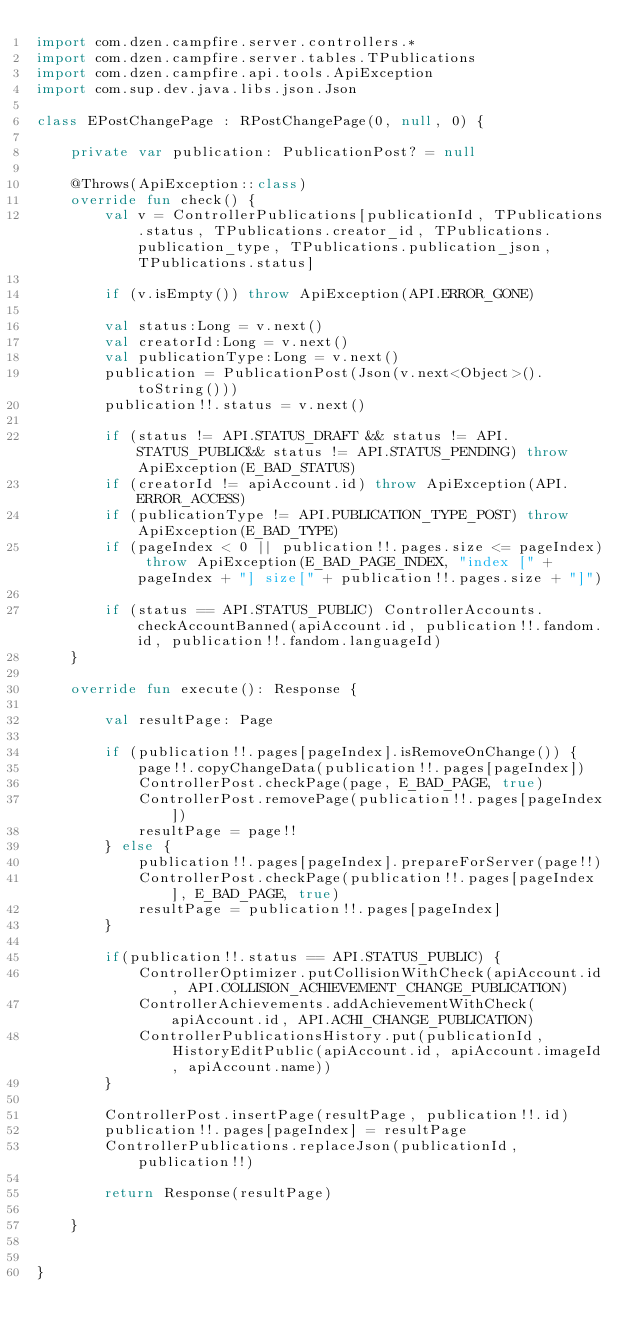<code> <loc_0><loc_0><loc_500><loc_500><_Kotlin_>import com.dzen.campfire.server.controllers.*
import com.dzen.campfire.server.tables.TPublications
import com.dzen.campfire.api.tools.ApiException
import com.sup.dev.java.libs.json.Json

class EPostChangePage : RPostChangePage(0, null, 0) {

    private var publication: PublicationPost? = null

    @Throws(ApiException::class)
    override fun check() {
        val v = ControllerPublications[publicationId, TPublications.status, TPublications.creator_id, TPublications.publication_type, TPublications.publication_json, TPublications.status]

        if (v.isEmpty()) throw ApiException(API.ERROR_GONE)

        val status:Long = v.next()
        val creatorId:Long = v.next()
        val publicationType:Long = v.next()
        publication = PublicationPost(Json(v.next<Object>().toString()))
        publication!!.status = v.next()

        if (status != API.STATUS_DRAFT && status != API.STATUS_PUBLIC&& status != API.STATUS_PENDING) throw ApiException(E_BAD_STATUS)
        if (creatorId != apiAccount.id) throw ApiException(API.ERROR_ACCESS)
        if (publicationType != API.PUBLICATION_TYPE_POST) throw ApiException(E_BAD_TYPE)
        if (pageIndex < 0 || publication!!.pages.size <= pageIndex) throw ApiException(E_BAD_PAGE_INDEX, "index [" + pageIndex + "] size[" + publication!!.pages.size + "]")

        if (status == API.STATUS_PUBLIC) ControllerAccounts.checkAccountBanned(apiAccount.id, publication!!.fandom.id, publication!!.fandom.languageId)
    }

    override fun execute(): Response {

        val resultPage: Page

        if (publication!!.pages[pageIndex].isRemoveOnChange()) {
            page!!.copyChangeData(publication!!.pages[pageIndex])
            ControllerPost.checkPage(page, E_BAD_PAGE, true)
            ControllerPost.removePage(publication!!.pages[pageIndex])
            resultPage = page!!
        } else {
            publication!!.pages[pageIndex].prepareForServer(page!!)
            ControllerPost.checkPage(publication!!.pages[pageIndex], E_BAD_PAGE, true)
            resultPage = publication!!.pages[pageIndex]
        }

        if(publication!!.status == API.STATUS_PUBLIC) {
            ControllerOptimizer.putCollisionWithCheck(apiAccount.id, API.COLLISION_ACHIEVEMENT_CHANGE_PUBLICATION)
            ControllerAchievements.addAchievementWithCheck(apiAccount.id, API.ACHI_CHANGE_PUBLICATION)
            ControllerPublicationsHistory.put(publicationId, HistoryEditPublic(apiAccount.id, apiAccount.imageId, apiAccount.name))
        }

        ControllerPost.insertPage(resultPage, publication!!.id)
        publication!!.pages[pageIndex] = resultPage
        ControllerPublications.replaceJson(publicationId, publication!!)

        return Response(resultPage)

    }


}
</code> 